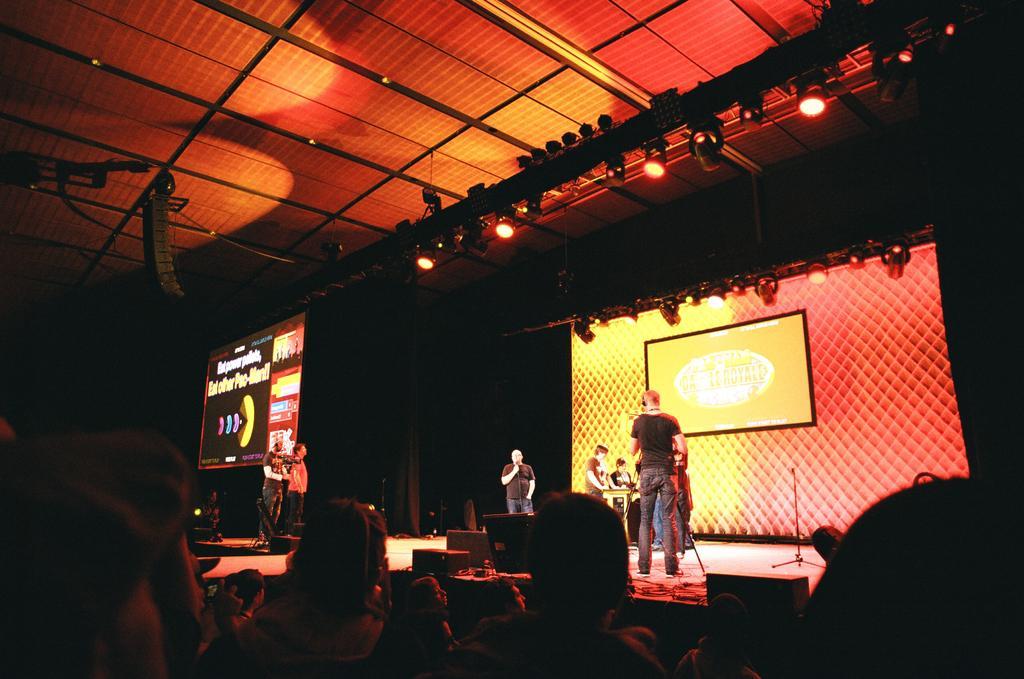Can you describe this image briefly? In this picture we can observe a person standing on the stage and holding a mic in his hand. There are some persons standing on the stage. We can observe some people sitting in the chair in front of the stage. There is a screen behind the persons standing on the stage. The screen is in yellow and red color. We can observe some red color lights. On the left side we can observe projector display screen. The background is completely dark. 